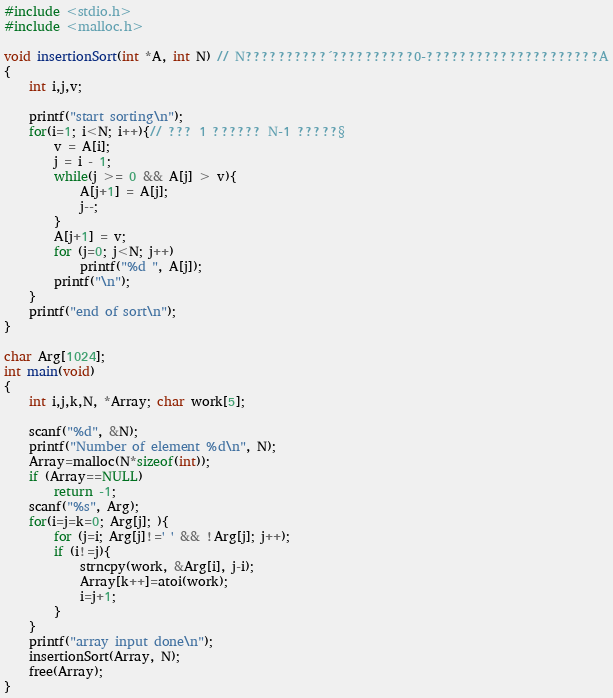Convert code to text. <code><loc_0><loc_0><loc_500><loc_500><_C_>#include <stdio.h>
#include <malloc.h>

void insertionSort(int *A, int N) // N??????????´??????????0-?????????????????????A
{
    int i,j,v;

    printf("start sorting\n");
    for(i=1; i<N; i++){// ??? 1 ?????? N-1 ?????§
        v = A[i];
        j = i - 1;
        while(j >= 0 && A[j] > v){
            A[j+1] = A[j];
            j--;
        }
        A[j+1] = v;
        for (j=0; j<N; j++)
            printf("%d ", A[j]);
        printf("\n");
    }
    printf("end of sort\n");
}

char Arg[1024];
int main(void)
{
    int i,j,k,N, *Array; char work[5];

    scanf("%d", &N);
    printf("Number of element %d\n", N);
    Array=malloc(N*sizeof(int));
    if (Array==NULL)
        return -1;
    scanf("%s", Arg);
    for(i=j=k=0; Arg[j]; ){
        for (j=i; Arg[j]!=' ' && !Arg[j]; j++);
        if (i!=j){
            strncpy(work, &Arg[i], j-i);
            Array[k++]=atoi(work);
            i=j+1;
        }
    }
    printf("array input done\n");
    insertionSort(Array, N);
    free(Array);
}</code> 